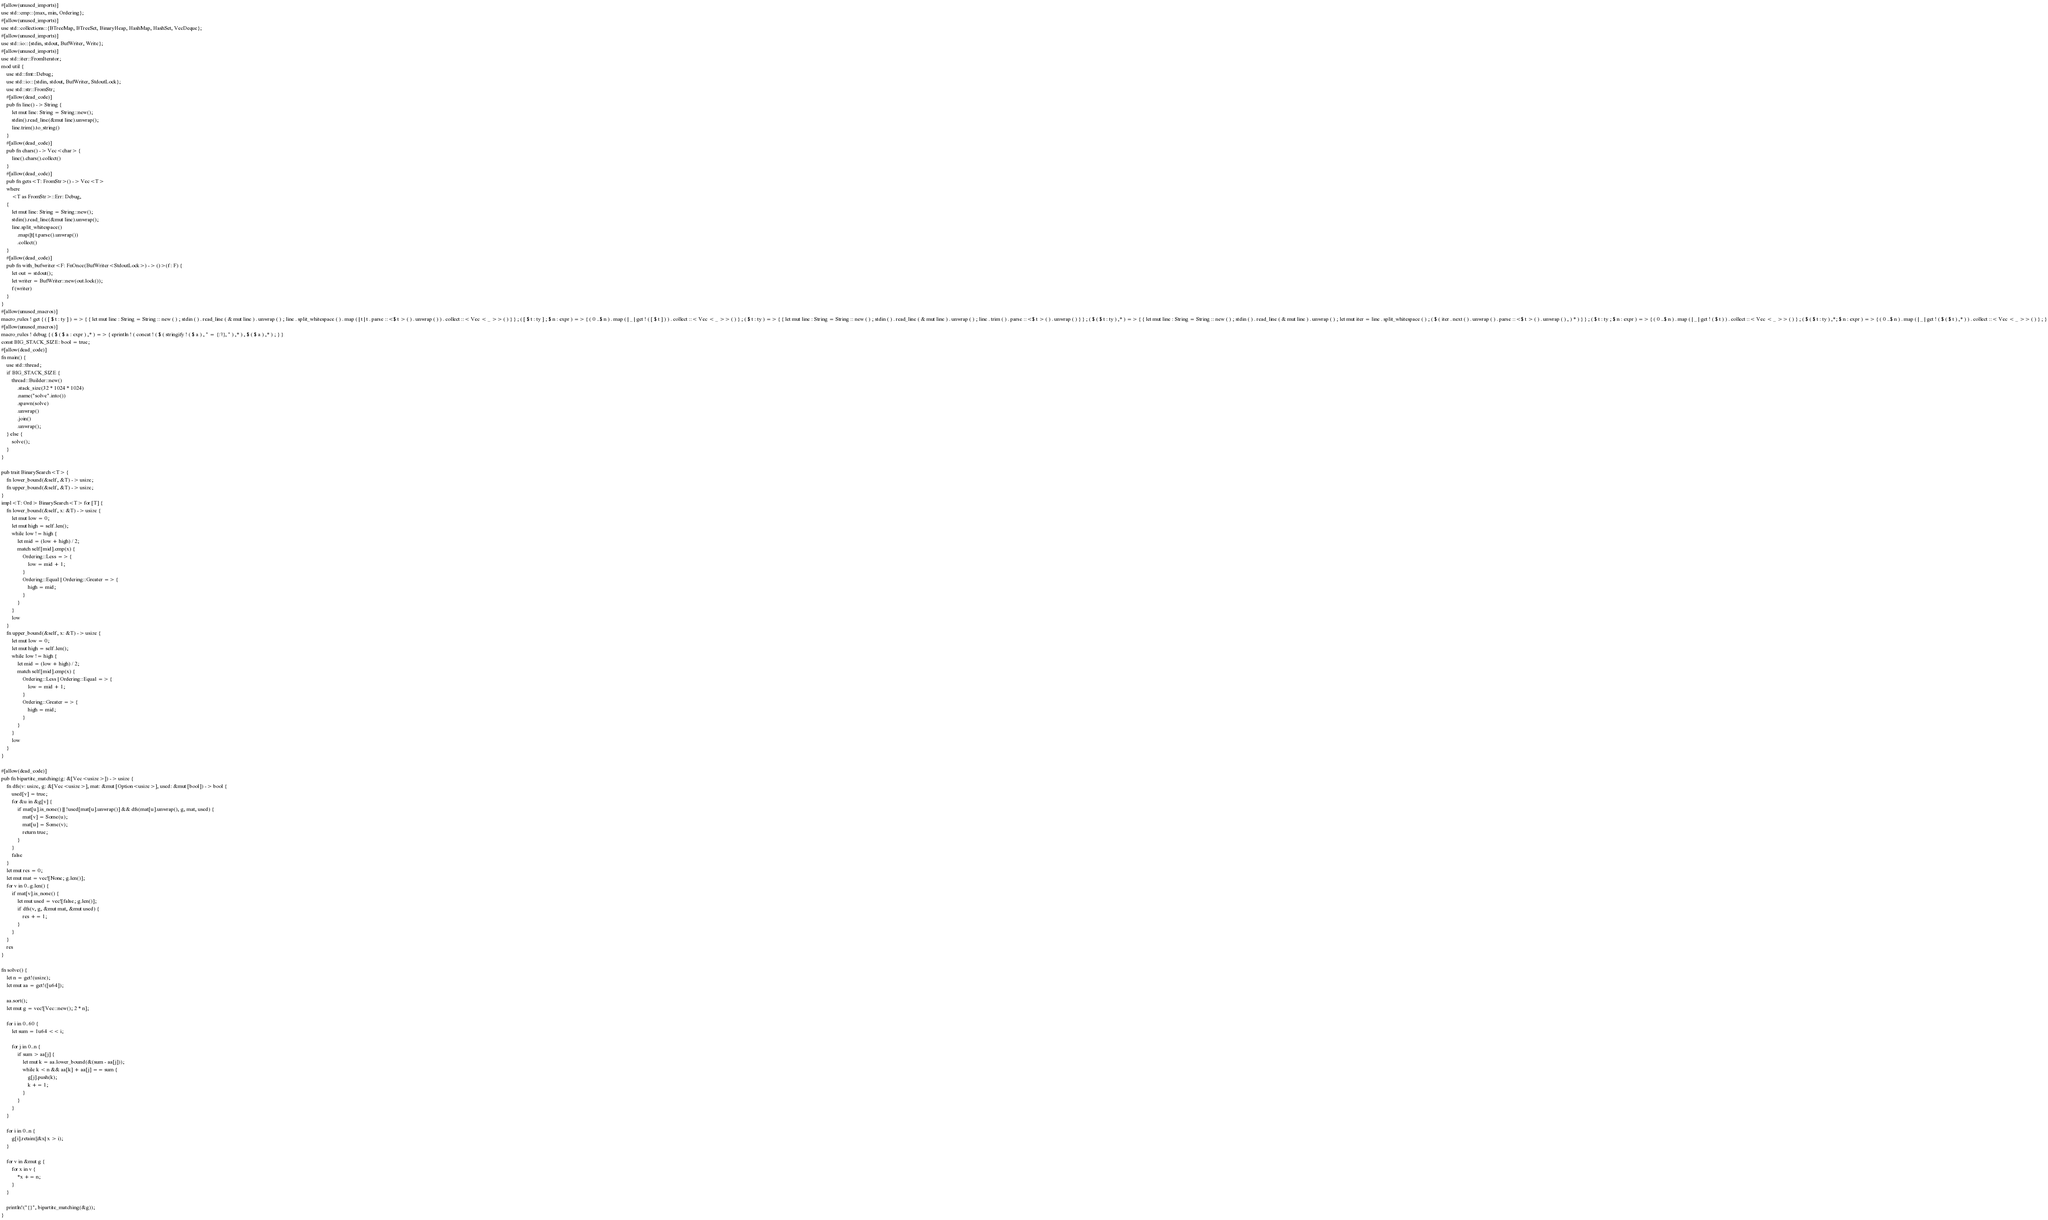<code> <loc_0><loc_0><loc_500><loc_500><_Rust_>#[allow(unused_imports)]
use std::cmp::{max, min, Ordering};
#[allow(unused_imports)]
use std::collections::{BTreeMap, BTreeSet, BinaryHeap, HashMap, HashSet, VecDeque};
#[allow(unused_imports)]
use std::io::{stdin, stdout, BufWriter, Write};
#[allow(unused_imports)]
use std::iter::FromIterator;
mod util {
    use std::fmt::Debug;
    use std::io::{stdin, stdout, BufWriter, StdoutLock};
    use std::str::FromStr;
    #[allow(dead_code)]
    pub fn line() -> String {
        let mut line: String = String::new();
        stdin().read_line(&mut line).unwrap();
        line.trim().to_string()
    }
    #[allow(dead_code)]
    pub fn chars() -> Vec<char> {
        line().chars().collect()
    }
    #[allow(dead_code)]
    pub fn gets<T: FromStr>() -> Vec<T>
    where
        <T as FromStr>::Err: Debug,
    {
        let mut line: String = String::new();
        stdin().read_line(&mut line).unwrap();
        line.split_whitespace()
            .map(|t| t.parse().unwrap())
            .collect()
    }
    #[allow(dead_code)]
    pub fn with_bufwriter<F: FnOnce(BufWriter<StdoutLock>) -> ()>(f: F) {
        let out = stdout();
        let writer = BufWriter::new(out.lock());
        f(writer)
    }
}
#[allow(unused_macros)]
macro_rules ! get { ( [ $ t : ty ] ) => { { let mut line : String = String :: new ( ) ; stdin ( ) . read_line ( & mut line ) . unwrap ( ) ; line . split_whitespace ( ) . map ( | t | t . parse ::<$ t > ( ) . unwrap ( ) ) . collect ::< Vec < _ >> ( ) } } ; ( [ $ t : ty ] ; $ n : expr ) => { ( 0 ..$ n ) . map ( | _ | get ! ( [ $ t ] ) ) . collect ::< Vec < _ >> ( ) } ; ( $ t : ty ) => { { let mut line : String = String :: new ( ) ; stdin ( ) . read_line ( & mut line ) . unwrap ( ) ; line . trim ( ) . parse ::<$ t > ( ) . unwrap ( ) } } ; ( $ ( $ t : ty ) ,* ) => { { let mut line : String = String :: new ( ) ; stdin ( ) . read_line ( & mut line ) . unwrap ( ) ; let mut iter = line . split_whitespace ( ) ; ( $ ( iter . next ( ) . unwrap ( ) . parse ::<$ t > ( ) . unwrap ( ) , ) * ) } } ; ( $ t : ty ; $ n : expr ) => { ( 0 ..$ n ) . map ( | _ | get ! ( $ t ) ) . collect ::< Vec < _ >> ( ) } ; ( $ ( $ t : ty ) ,*; $ n : expr ) => { ( 0 ..$ n ) . map ( | _ | get ! ( $ ( $ t ) ,* ) ) . collect ::< Vec < _ >> ( ) } ; }
#[allow(unused_macros)]
macro_rules ! debug { ( $ ( $ a : expr ) ,* ) => { eprintln ! ( concat ! ( $ ( stringify ! ( $ a ) , " = {:?}, " ) ,* ) , $ ( $ a ) ,* ) ; } }
const BIG_STACK_SIZE: bool = true;
#[allow(dead_code)]
fn main() {
    use std::thread;
    if BIG_STACK_SIZE {
        thread::Builder::new()
            .stack_size(32 * 1024 * 1024)
            .name("solve".into())
            .spawn(solve)
            .unwrap()
            .join()
            .unwrap();
    } else {
        solve();
    }
}

pub trait BinarySearch<T> {
    fn lower_bound(&self, &T) -> usize;
    fn upper_bound(&self, &T) -> usize;
}
impl<T: Ord> BinarySearch<T> for [T] {
    fn lower_bound(&self, x: &T) -> usize {
        let mut low = 0;
        let mut high = self.len();
        while low != high {
            let mid = (low + high) / 2;
            match self[mid].cmp(x) {
                Ordering::Less => {
                    low = mid + 1;
                }
                Ordering::Equal | Ordering::Greater => {
                    high = mid;
                }
            }
        }
        low
    }
    fn upper_bound(&self, x: &T) -> usize {
        let mut low = 0;
        let mut high = self.len();
        while low != high {
            let mid = (low + high) / 2;
            match self[mid].cmp(x) {
                Ordering::Less | Ordering::Equal => {
                    low = mid + 1;
                }
                Ordering::Greater => {
                    high = mid;
                }
            }
        }
        low
    }
}

#[allow(dead_code)]
pub fn bipartite_matching(g: &[Vec<usize>]) -> usize {
    fn dfs(v: usize, g: &[Vec<usize>], mat: &mut [Option<usize>], used: &mut [bool]) -> bool {
        used[v] = true;
        for &u in &g[v] {
            if mat[u].is_none() || !used[mat[u].unwrap()] && dfs(mat[u].unwrap(), g, mat, used) {
                mat[v] = Some(u);
                mat[u] = Some(v);
                return true;
            }
        }
        false
    }
    let mut res = 0;
    let mut mat = vec![None; g.len()];
    for v in 0..g.len() {
        if mat[v].is_none() {
            let mut used = vec![false; g.len()];
            if dfs(v, g, &mut mat, &mut used) {
                res += 1;
            }
        }
    }
    res
}

fn solve() {
    let n = get!(usize);
    let mut aa = get!([u64]);

    aa.sort();
    let mut g = vec![Vec::new(); 2 * n];

    for i in 0..60 {
        let sum = 1u64 << i;

        for j in 0..n {
            if sum > aa[j] {
                let mut k = aa.lower_bound(&(sum - aa[j]));
                while k < n && aa[k] + aa[j] == sum {
                    g[j].push(k);
                    k += 1;
                }
            }
        }
    }

    for i in 0..n {
        g[i].retain(|&x| x > i);
    }

    for v in &mut g {
        for x in v {
            *x += n;
        }
    }

    println!("{}", bipartite_matching(&g));
}
</code> 